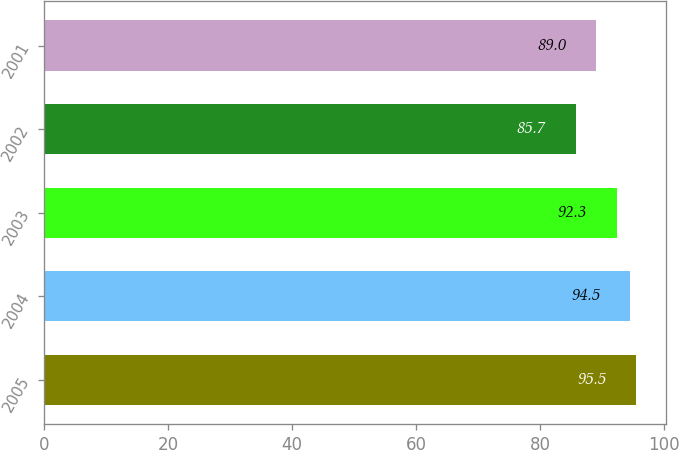<chart> <loc_0><loc_0><loc_500><loc_500><bar_chart><fcel>2005<fcel>2004<fcel>2003<fcel>2002<fcel>2001<nl><fcel>95.5<fcel>94.5<fcel>92.3<fcel>85.7<fcel>89<nl></chart> 